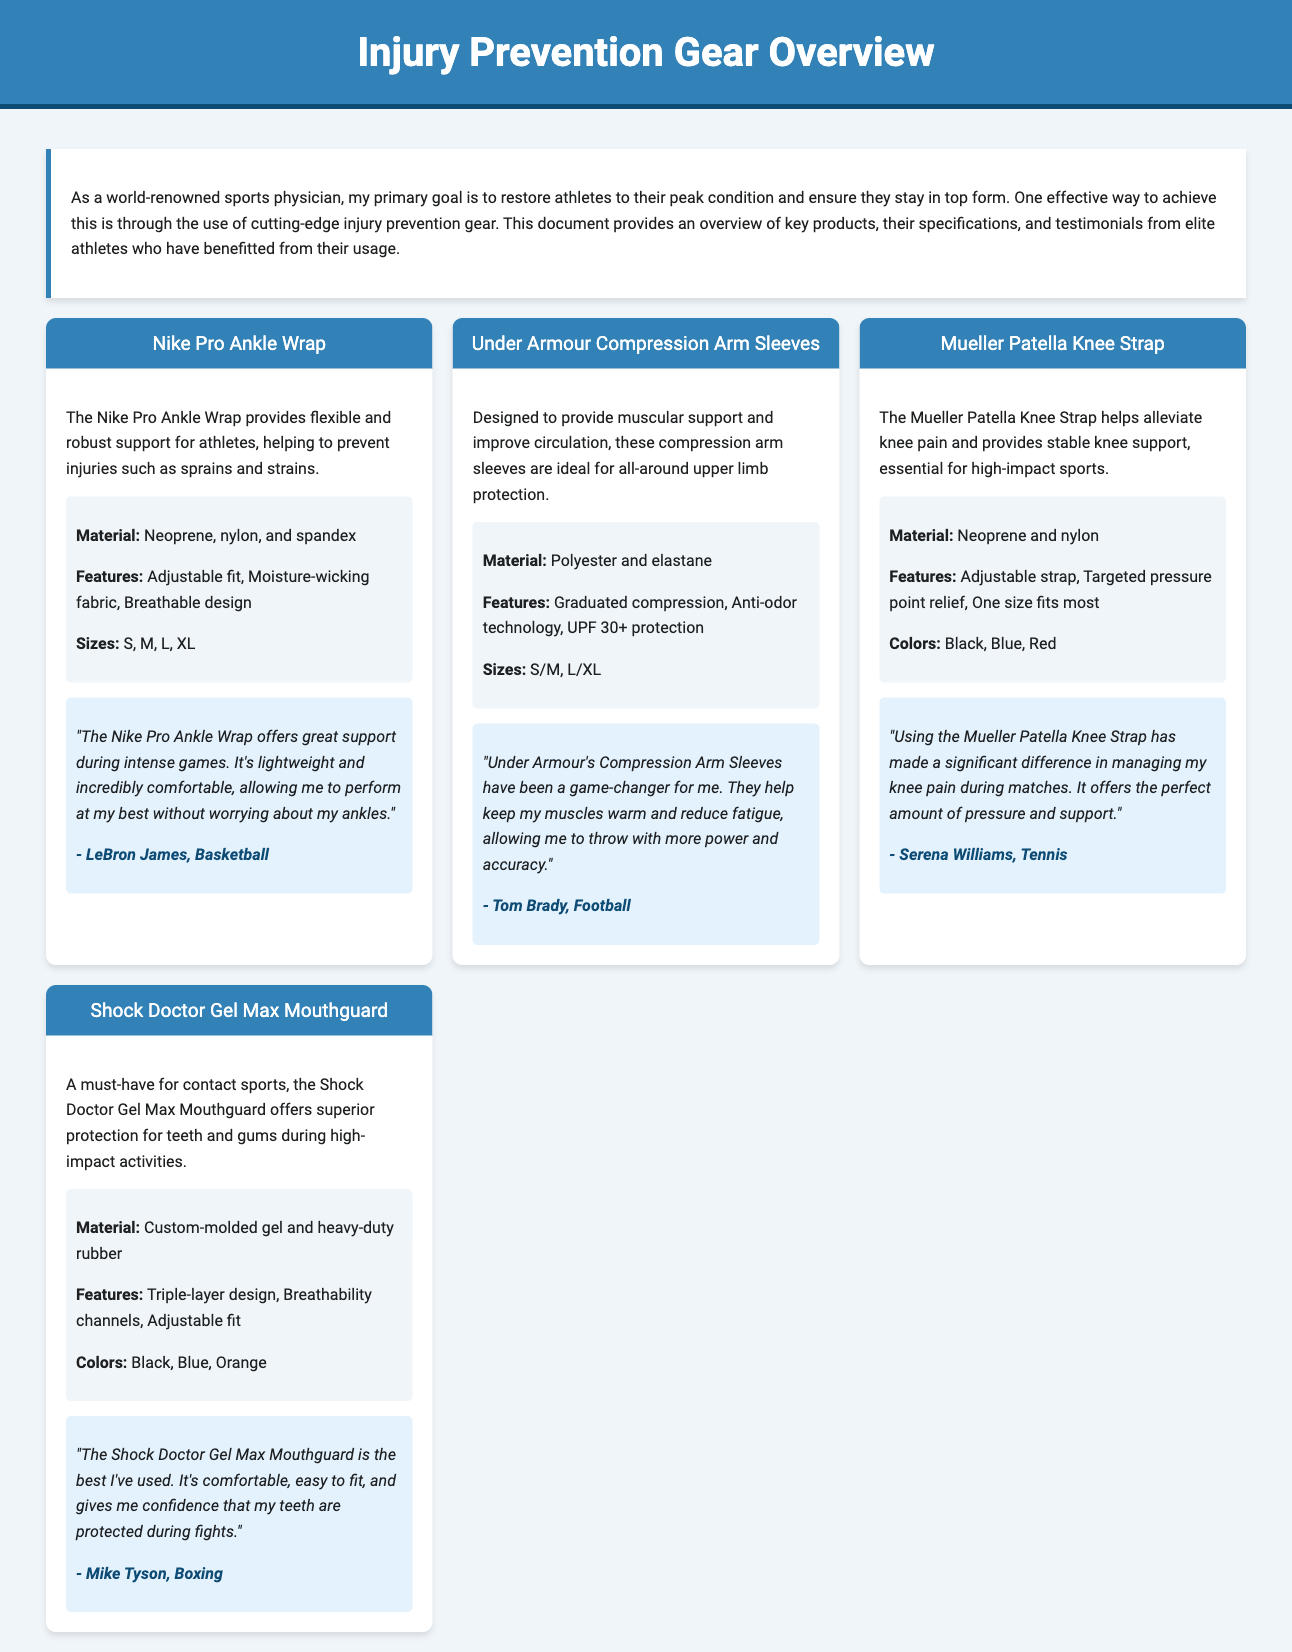what is the material of the Nike Pro Ankle Wrap? The Nike Pro Ankle Wrap is made of neoprene, nylon, and spandex.
Answer: neoprene, nylon, and spandex what athlete uses the Under Armour Compression Arm Sleeves? The Under Armour Compression Arm Sleeves are used by Tom Brady.
Answer: Tom Brady how many colors does the Mueller Patella Knee Strap come in? The Mueller Patella Knee Strap is available in three colors.
Answer: three what feature is common in the Shock Doctor Gel Max Mouthguard? One common feature of the Shock Doctor Gel Max Mouthguard is the adjustable fit.
Answer: adjustable fit which product provides targeted pressure point relief? The Mueller Patella Knee Strap provides targeted pressure point relief.
Answer: Mueller Patella Knee Strap what is the primary goal of using injury prevention gear? The primary goal is to prevent injuries and restore athletes to peak condition.
Answer: prevent injuries which athlete stated that the Nike Pro Ankle Wrap is lightweight? LeBron James stated that the Nike Pro Ankle Wrap is lightweight.
Answer: LeBron James what sizes are available for the Under Armour Compression Arm Sleeves? The Under Armour Compression Arm Sleeves are available in S/M and L/XL sizes.
Answer: S/M, L/XL what is the unique feature of the material in the Shock Doctor Gel Max Mouthguard? The material of the Shock Doctor Gel Max Mouthguard is custom-molded gel and heavy-duty rubber.
Answer: custom-molded gel and heavy-duty rubber 